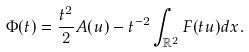<formula> <loc_0><loc_0><loc_500><loc_500>\Phi ( t ) = \frac { t ^ { 2 } } { 2 } A ( u ) - t ^ { - 2 } \int _ { \mathbb { R } ^ { 2 } } F ( t u ) d x .</formula> 